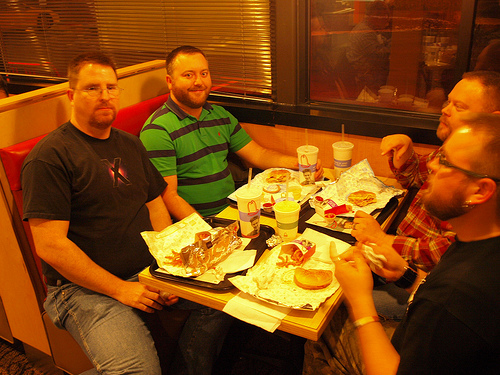<image>
Is the juice next to the burger? Yes. The juice is positioned adjacent to the burger, located nearby in the same general area. 